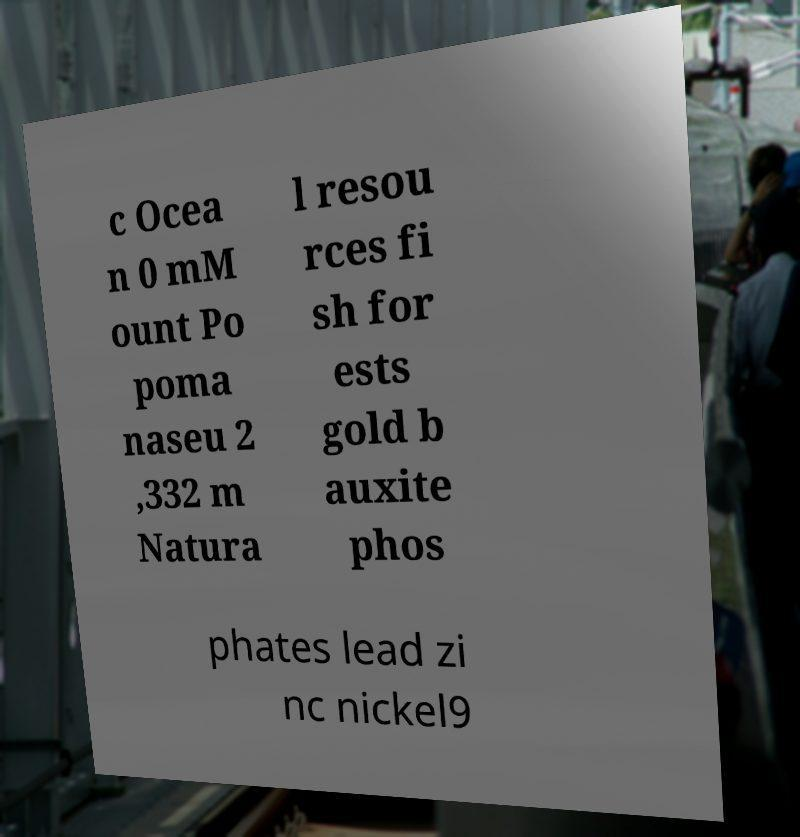There's text embedded in this image that I need extracted. Can you transcribe it verbatim? c Ocea n 0 mM ount Po poma naseu 2 ,332 m Natura l resou rces fi sh for ests gold b auxite phos phates lead zi nc nickel9 